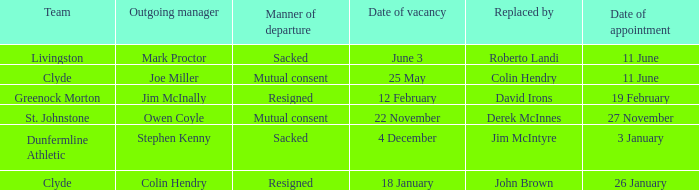Tell me the outgoing manager for 22 november date of vacancy Owen Coyle. 